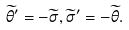Convert formula to latex. <formula><loc_0><loc_0><loc_500><loc_500>\widetilde { \theta } ^ { \prime } = - \widetilde { \sigma } , \widetilde { \sigma } ^ { \prime } = - \widetilde { \theta } .</formula> 